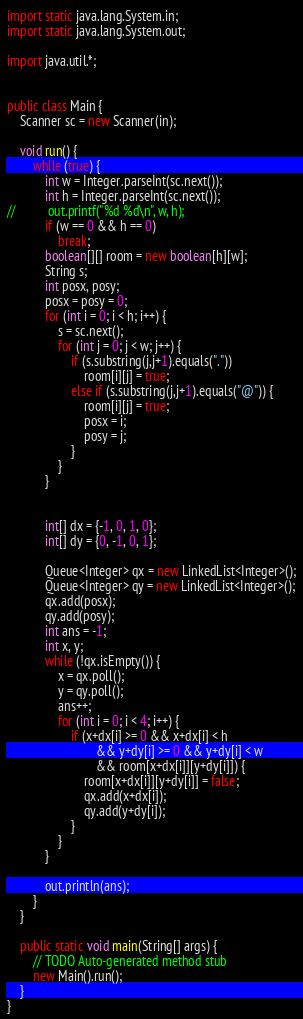<code> <loc_0><loc_0><loc_500><loc_500><_Java_>import static java.lang.System.in;
import static java.lang.System.out;

import java.util.*;


public class Main {
	Scanner sc = new Scanner(in);
	
	void run() {
		while (true) {
			int w = Integer.parseInt(sc.next());
			int h = Integer.parseInt(sc.next());
//			out.printf("%d %d\n", w, h);
			if (w == 0 && h == 0)
				break;
			boolean[][] room = new boolean[h][w];
			String s;
			int posx, posy;
			posx = posy = 0;
			for (int i = 0; i < h; i++) {
				s = sc.next();
				for (int j = 0; j < w; j++) {
					if (s.substring(j,j+1).equals("."))
						room[i][j] = true;
					else if (s.substring(j,j+1).equals("@")) {
						room[i][j] = true;
						posx = i;
						posy = j;
					}
				}
			}

			
			int[] dx = {-1, 0, 1, 0};
			int[] dy = {0, -1, 0, 1};
			
			Queue<Integer> qx = new LinkedList<Integer>();
			Queue<Integer> qy = new LinkedList<Integer>();
			qx.add(posx);
			qy.add(posy);
			int ans = -1;
			int x, y;
			while (!qx.isEmpty()) {
				x = qx.poll();
				y = qy.poll();
				ans++;
				for (int i = 0; i < 4; i++) {
					if (x+dx[i] >= 0 && x+dx[i] < h 
							&& y+dy[i] >= 0 && y+dy[i] < w
							&& room[x+dx[i]][y+dy[i]]) {
						room[x+dx[i]][y+dy[i]] = false;
						qx.add(x+dx[i]);
						qy.add(y+dy[i]);
					}
				}
			}
			
			out.println(ans);
		}
	}
	
	public static void main(String[] args) {
		// TODO Auto-generated method stub
		new Main().run();
	}
}</code> 